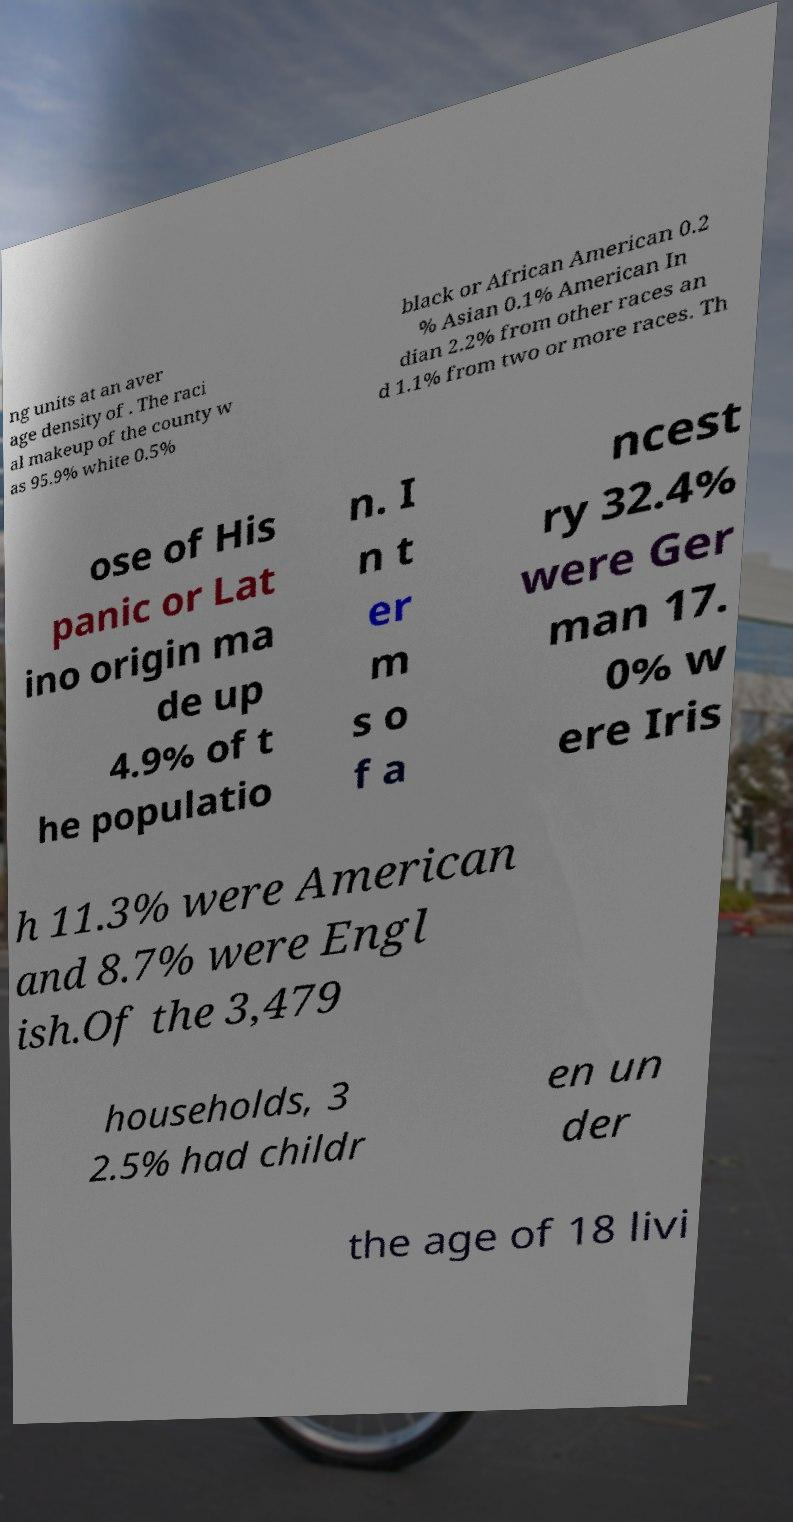Please identify and transcribe the text found in this image. ng units at an aver age density of . The raci al makeup of the county w as 95.9% white 0.5% black or African American 0.2 % Asian 0.1% American In dian 2.2% from other races an d 1.1% from two or more races. Th ose of His panic or Lat ino origin ma de up 4.9% of t he populatio n. I n t er m s o f a ncest ry 32.4% were Ger man 17. 0% w ere Iris h 11.3% were American and 8.7% were Engl ish.Of the 3,479 households, 3 2.5% had childr en un der the age of 18 livi 